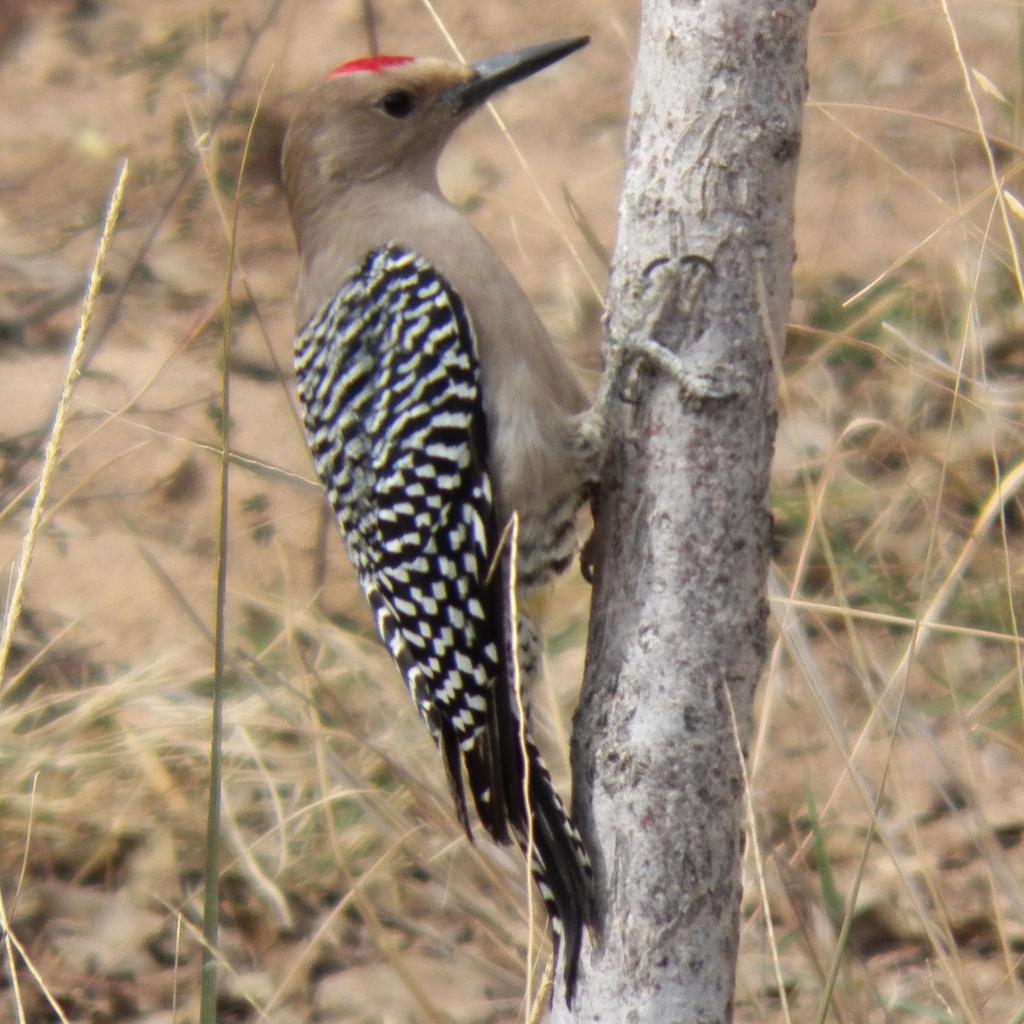What type of animal is in the image? There is a bird in the image. Where is the bird located on the tree? The bird is on the trunk of the tree. Is the bird located anywhere else in the image? Yes, the bird is also on the grass. What type of cakes is the bird delivering in the image? There are no cakes present in the image, and the bird is not delivering anything. 